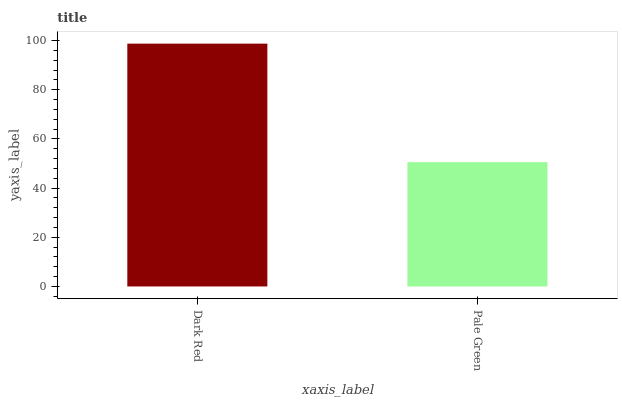Is Pale Green the minimum?
Answer yes or no. Yes. Is Dark Red the maximum?
Answer yes or no. Yes. Is Pale Green the maximum?
Answer yes or no. No. Is Dark Red greater than Pale Green?
Answer yes or no. Yes. Is Pale Green less than Dark Red?
Answer yes or no. Yes. Is Pale Green greater than Dark Red?
Answer yes or no. No. Is Dark Red less than Pale Green?
Answer yes or no. No. Is Dark Red the high median?
Answer yes or no. Yes. Is Pale Green the low median?
Answer yes or no. Yes. Is Pale Green the high median?
Answer yes or no. No. Is Dark Red the low median?
Answer yes or no. No. 